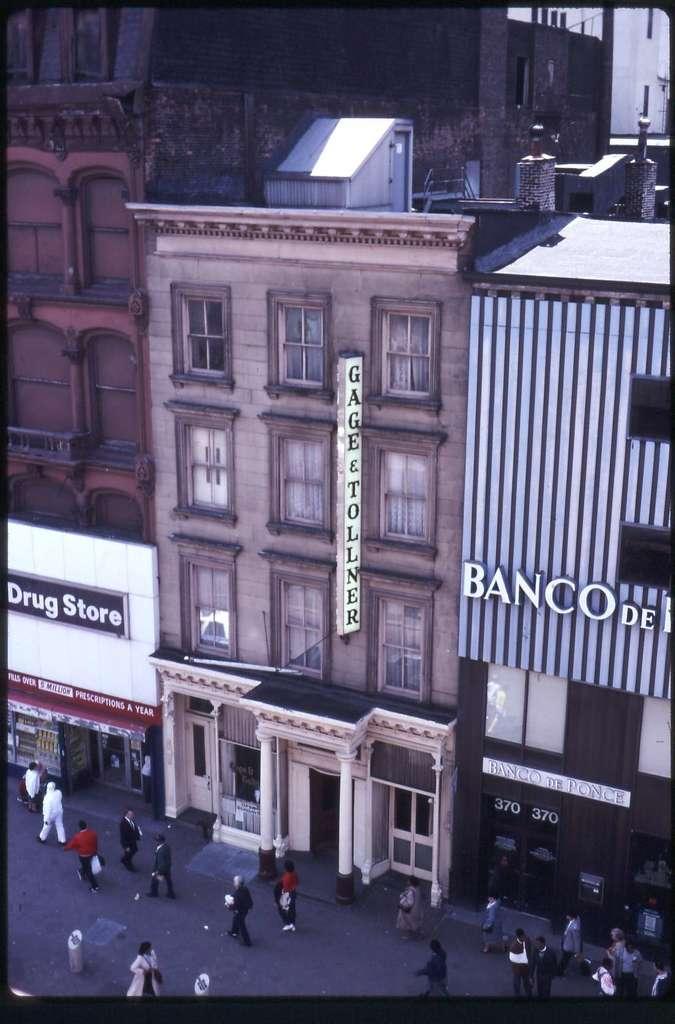How would you summarize this image in a sentence or two? In the image there are buildings, it looks like they are some shopping stores and in front of those buildings there are few people. 